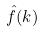<formula> <loc_0><loc_0><loc_500><loc_500>\hat { f } ( k )</formula> 